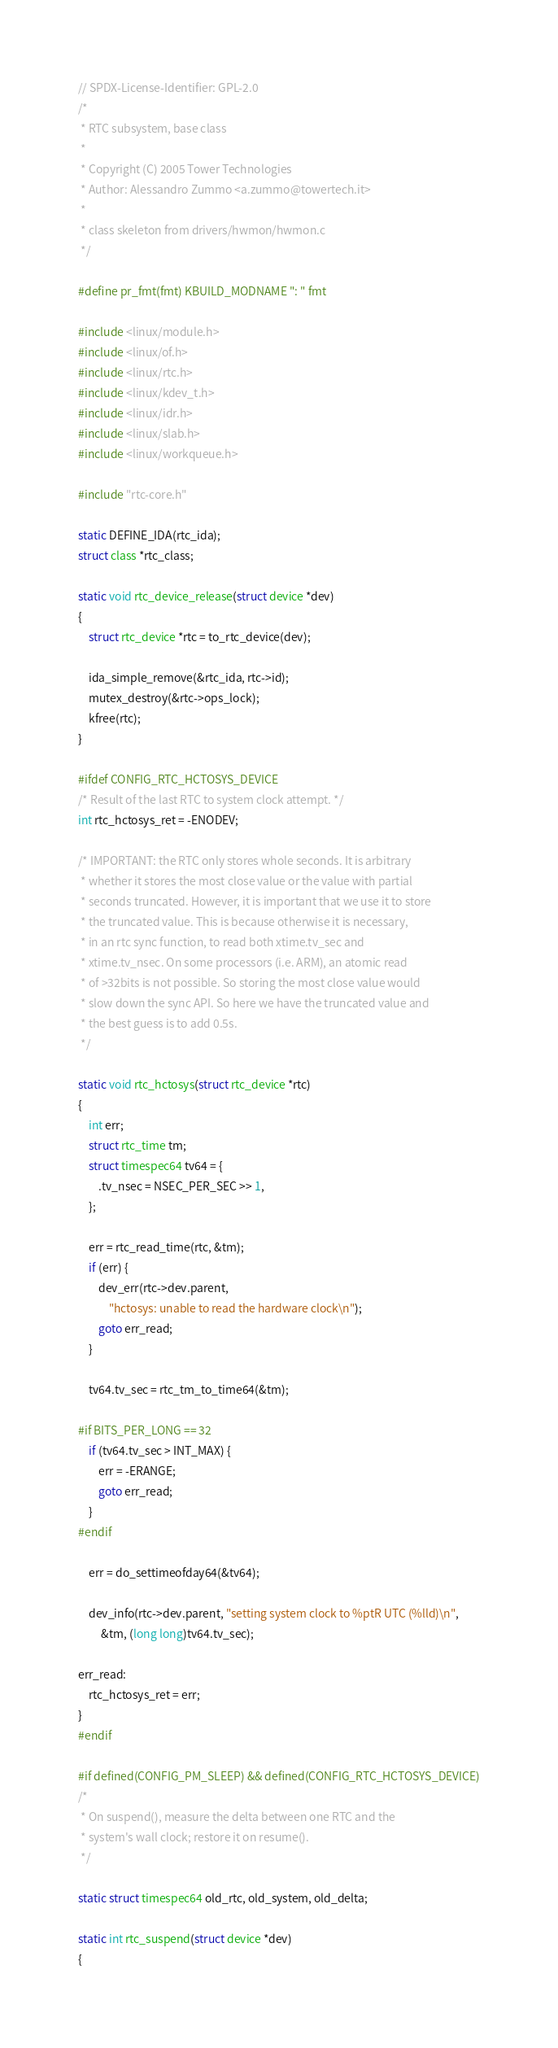<code> <loc_0><loc_0><loc_500><loc_500><_C_>// SPDX-License-Identifier: GPL-2.0
/*
 * RTC subsystem, base class
 *
 * Copyright (C) 2005 Tower Technologies
 * Author: Alessandro Zummo <a.zummo@towertech.it>
 *
 * class skeleton from drivers/hwmon/hwmon.c
 */

#define pr_fmt(fmt) KBUILD_MODNAME ": " fmt

#include <linux/module.h>
#include <linux/of.h>
#include <linux/rtc.h>
#include <linux/kdev_t.h>
#include <linux/idr.h>
#include <linux/slab.h>
#include <linux/workqueue.h>

#include "rtc-core.h"

static DEFINE_IDA(rtc_ida);
struct class *rtc_class;

static void rtc_device_release(struct device *dev)
{
	struct rtc_device *rtc = to_rtc_device(dev);

	ida_simple_remove(&rtc_ida, rtc->id);
	mutex_destroy(&rtc->ops_lock);
	kfree(rtc);
}

#ifdef CONFIG_RTC_HCTOSYS_DEVICE
/* Result of the last RTC to system clock attempt. */
int rtc_hctosys_ret = -ENODEV;

/* IMPORTANT: the RTC only stores whole seconds. It is arbitrary
 * whether it stores the most close value or the value with partial
 * seconds truncated. However, it is important that we use it to store
 * the truncated value. This is because otherwise it is necessary,
 * in an rtc sync function, to read both xtime.tv_sec and
 * xtime.tv_nsec. On some processors (i.e. ARM), an atomic read
 * of >32bits is not possible. So storing the most close value would
 * slow down the sync API. So here we have the truncated value and
 * the best guess is to add 0.5s.
 */

static void rtc_hctosys(struct rtc_device *rtc)
{
	int err;
	struct rtc_time tm;
	struct timespec64 tv64 = {
		.tv_nsec = NSEC_PER_SEC >> 1,
	};

	err = rtc_read_time(rtc, &tm);
	if (err) {
		dev_err(rtc->dev.parent,
			"hctosys: unable to read the hardware clock\n");
		goto err_read;
	}

	tv64.tv_sec = rtc_tm_to_time64(&tm);

#if BITS_PER_LONG == 32
	if (tv64.tv_sec > INT_MAX) {
		err = -ERANGE;
		goto err_read;
	}
#endif

	err = do_settimeofday64(&tv64);

	dev_info(rtc->dev.parent, "setting system clock to %ptR UTC (%lld)\n",
		 &tm, (long long)tv64.tv_sec);

err_read:
	rtc_hctosys_ret = err;
}
#endif

#if defined(CONFIG_PM_SLEEP) && defined(CONFIG_RTC_HCTOSYS_DEVICE)
/*
 * On suspend(), measure the delta between one RTC and the
 * system's wall clock; restore it on resume().
 */

static struct timespec64 old_rtc, old_system, old_delta;

static int rtc_suspend(struct device *dev)
{</code> 